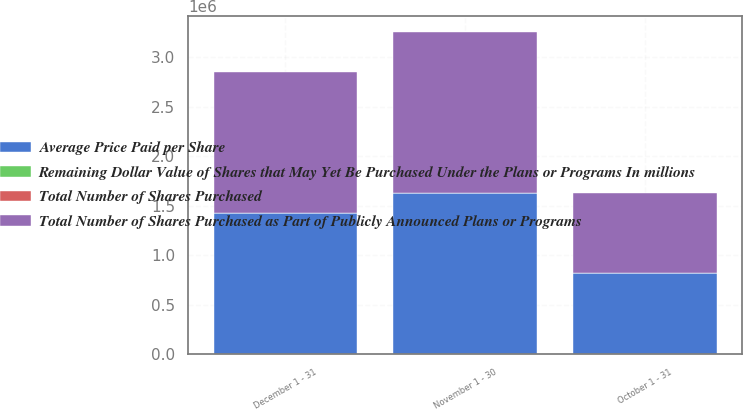Convert chart. <chart><loc_0><loc_0><loc_500><loc_500><stacked_bar_chart><ecel><fcel>October 1 - 31<fcel>November 1 - 30<fcel>December 1 - 31<nl><fcel>Average Price Paid per Share<fcel>819267<fcel>1.627e+06<fcel>1.42935e+06<nl><fcel>Remaining Dollar Value of Shares that May Yet Be Purchased Under the Plans or Programs In millions<fcel>18.01<fcel>17.96<fcel>18.43<nl><fcel>Total Number of Shares Purchased as Part of Publicly Announced Plans or Programs<fcel>810300<fcel>1.627e+06<fcel>1.42499e+06<nl><fcel>Total Number of Shares Purchased<fcel>471<fcel>441.8<fcel>415.5<nl></chart> 